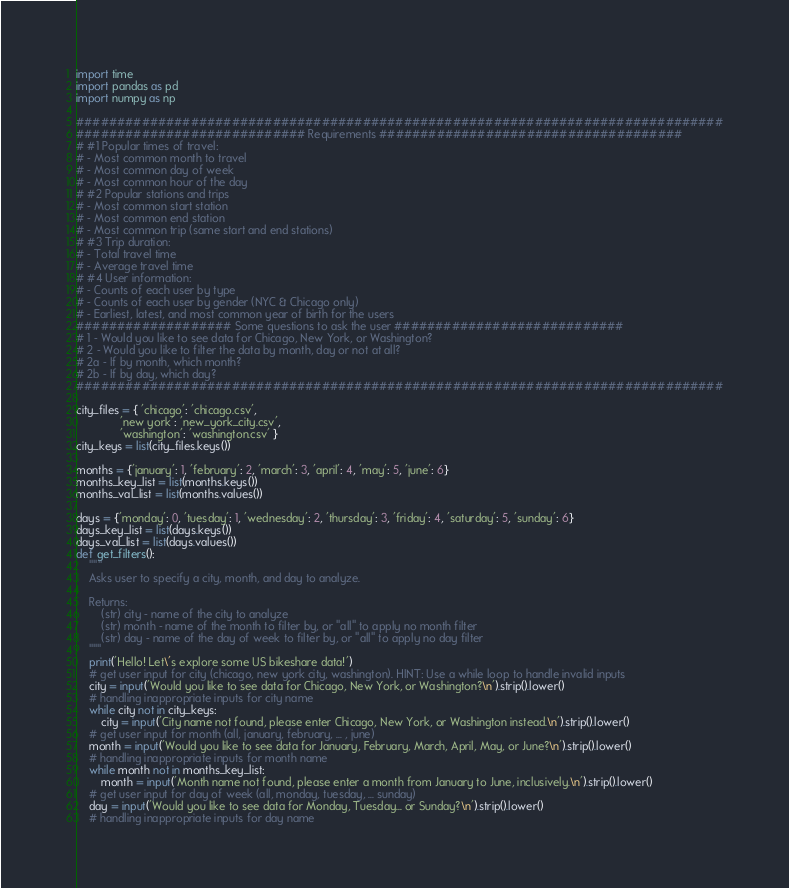Convert code to text. <code><loc_0><loc_0><loc_500><loc_500><_Python_>import time
import pandas as pd
import numpy as np

###############################################################################
############################ Requirements #####################################
# #1 Popular times of travel:
# - Most common month to travel
# - Most common day of week
# - Most common hour of the day
# #2 Popular stations and trips
# - Most common start station
# - Most common end station
# - Most common trip (same start and end stations)
# #3 Trip duration:
# - Total travel time
# - Average travel time
# #4 User information:
# - Counts of each user by type
# - Counts of each user by gender (NYC & Chicago only)
# - Earliest, latest, and most common year of birth for the users
################### Some questions to ask the user ############################
# 1 - Would you like to see data for Chicago, New York, or Washington?
# 2 - Would you like to filter the data by month, day or not at all?
# 2a - If by month, which month?
# 2b - If by day, which day?
###############################################################################

city_files = { 'chicago': 'chicago.csv',
              'new york': 'new_york_city.csv',
              'washington': 'washington.csv' }
city_keys = list(city_files.keys())

months = {'january': 1, 'february': 2, 'march': 3, 'april': 4, 'may': 5, 'june': 6}
months_key_list = list(months.keys())
months_val_list = list(months.values())

days = {'monday': 0, 'tuesday': 1, 'wednesday': 2, 'thursday': 3, 'friday': 4, 'saturday': 5, 'sunday': 6}
days_key_list = list(days.keys())
days_val_list = list(days.values())
def get_filters():
    """
    Asks user to specify a city, month, and day to analyze.

    Returns:
        (str) city - name of the city to analyze
        (str) month - name of the month to filter by, or "all" to apply no month filter
        (str) day - name of the day of week to filter by, or "all" to apply no day filter
    """
    print('Hello! Let\'s explore some US bikeshare data!')
    # get user input for city (chicago, new york city, washington). HINT: Use a while loop to handle invalid inputs
    city = input('Would you like to see data for Chicago, New York, or Washington?\n').strip().lower()
    # handling inappropriate inputs for city name
    while city not in city_keys:
        city = input('City name not found, please enter Chicago, New York, or Washington instead.\n').strip().lower()
    # get user input for month (all, january, february, ... , june)
    month = input('Would you like to see data for January, February, March, April, May, or June?\n').strip().lower()
    # handling inappropriate inputs for month name
    while month not in months_key_list:
        month = input('Month name not found, please enter a month from January to June, inclusively.\n').strip().lower()
    # get user input for day of week (all, monday, tuesday, ... sunday)
    day = input('Would you like to see data for Monday, Tuesday... or Sunday?\n').strip().lower()
    # handling inappropriate inputs for day name</code> 